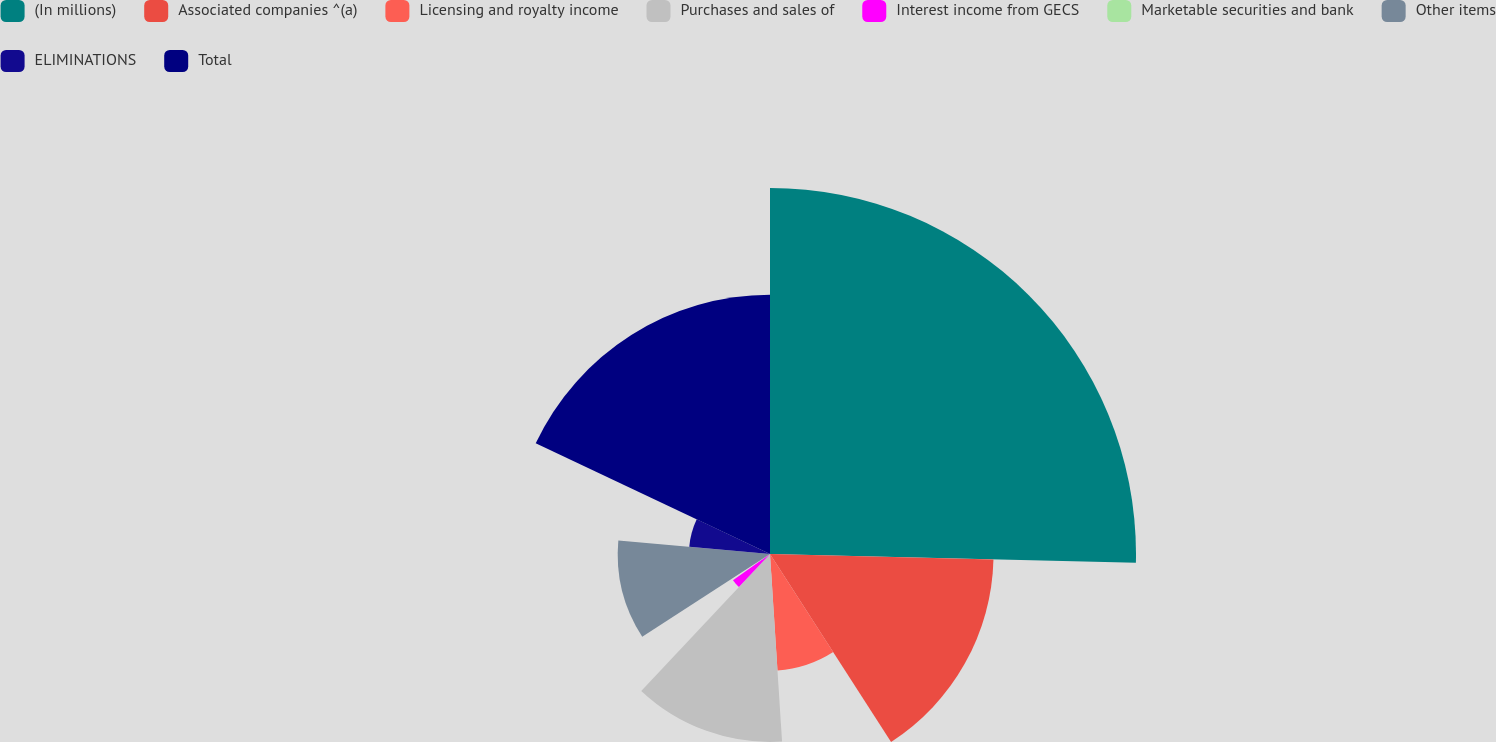Convert chart to OTSL. <chart><loc_0><loc_0><loc_500><loc_500><pie_chart><fcel>(In millions)<fcel>Associated companies ^(a)<fcel>Licensing and royalty income<fcel>Purchases and sales of<fcel>Interest income from GECS<fcel>Marketable securities and bank<fcel>Other items<fcel>ELIMINATIONS<fcel>Total<nl><fcel>25.38%<fcel>15.5%<fcel>8.09%<fcel>13.03%<fcel>3.15%<fcel>0.68%<fcel>10.56%<fcel>5.62%<fcel>17.97%<nl></chart> 